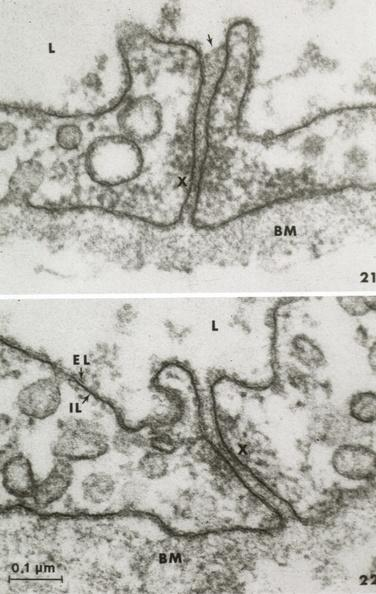s carcinoma present?
Answer the question using a single word or phrase. No 